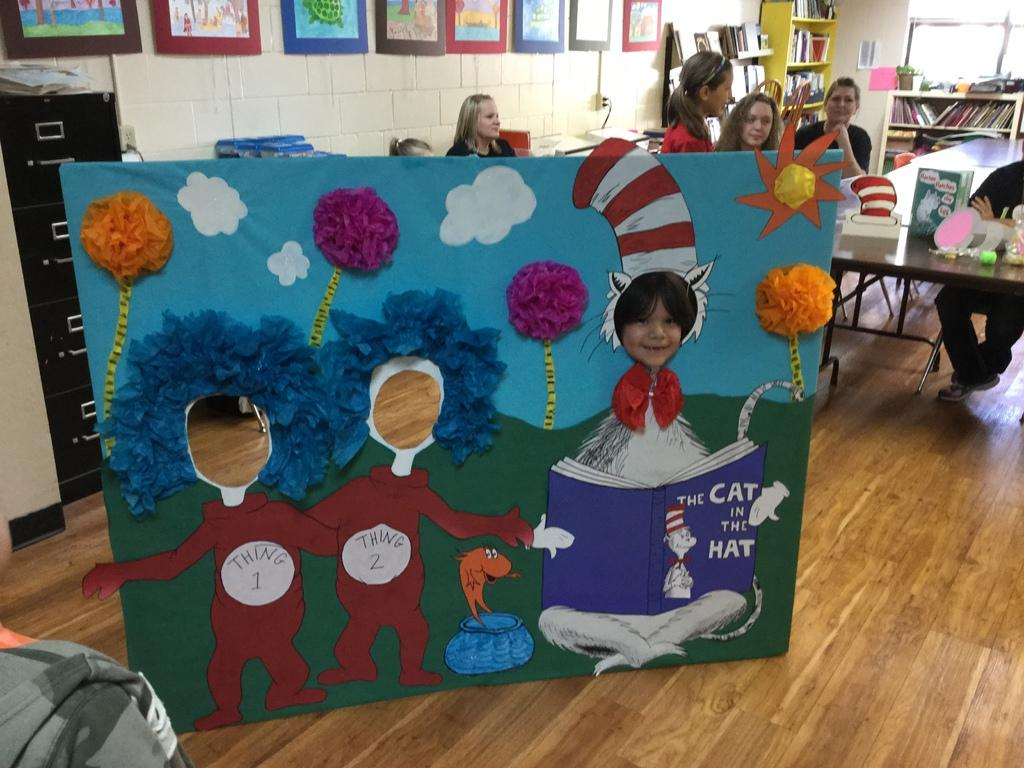<image>
Create a compact narrative representing the image presented. A child is putting their face through a hole in a Cat in the Hat standing cartoon board. 